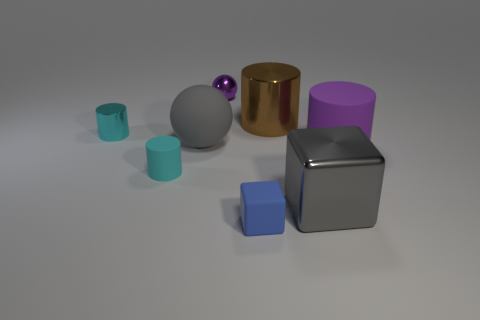Subtract all yellow cubes. How many cyan cylinders are left? 2 Subtract all small matte cylinders. How many cylinders are left? 3 Add 1 brown metallic objects. How many objects exist? 9 Subtract all brown cylinders. How many cylinders are left? 3 Subtract all gray cylinders. Subtract all blue balls. How many cylinders are left? 4 Add 4 tiny objects. How many tiny objects exist? 8 Subtract 1 gray blocks. How many objects are left? 7 Subtract all large yellow metal things. Subtract all large brown shiny cylinders. How many objects are left? 7 Add 6 large gray spheres. How many large gray spheres are left? 7 